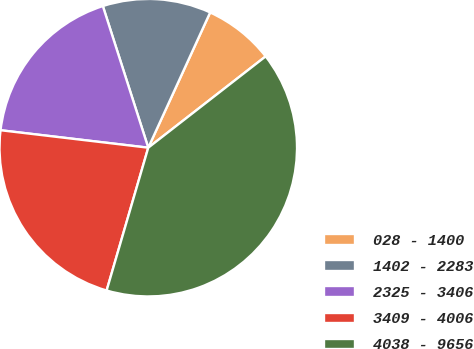Convert chart. <chart><loc_0><loc_0><loc_500><loc_500><pie_chart><fcel>028 - 1400<fcel>1402 - 2283<fcel>2325 - 3406<fcel>3409 - 4006<fcel>4038 - 9656<nl><fcel>7.65%<fcel>11.77%<fcel>18.19%<fcel>22.36%<fcel>40.04%<nl></chart> 